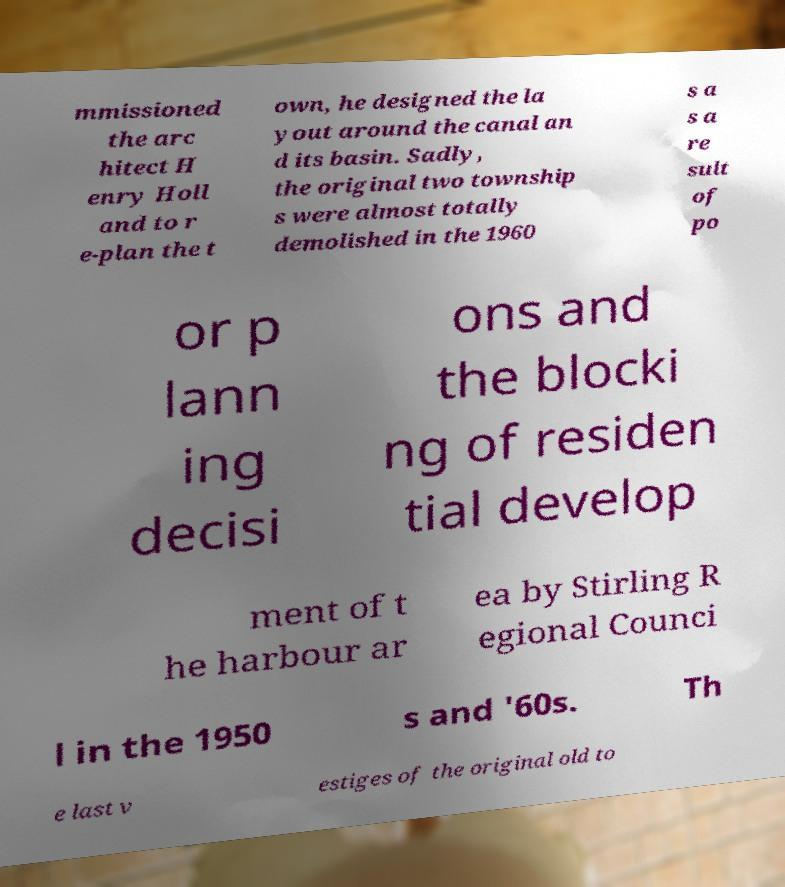Can you read and provide the text displayed in the image?This photo seems to have some interesting text. Can you extract and type it out for me? mmissioned the arc hitect H enry Holl and to r e-plan the t own, he designed the la yout around the canal an d its basin. Sadly, the original two township s were almost totally demolished in the 1960 s a s a re sult of po or p lann ing decisi ons and the blocki ng of residen tial develop ment of t he harbour ar ea by Stirling R egional Counci l in the 1950 s and '60s. Th e last v estiges of the original old to 